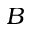<formula> <loc_0><loc_0><loc_500><loc_500>B</formula> 